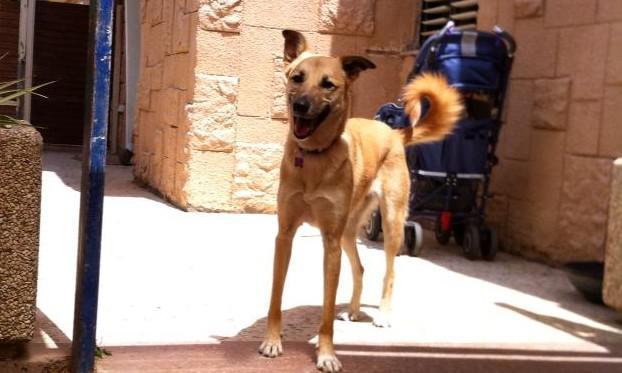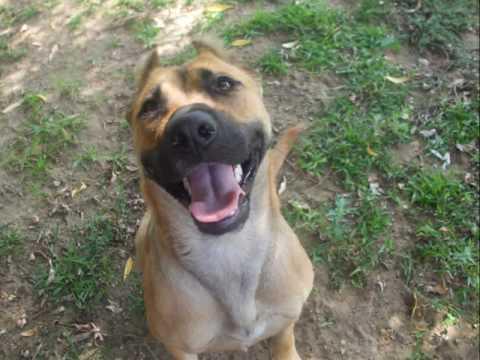The first image is the image on the left, the second image is the image on the right. Considering the images on both sides, is "The left image contains one person standing to the left of a dog." valid? Answer yes or no. No. The first image is the image on the left, the second image is the image on the right. For the images displayed, is the sentence "An image shows a person at the left, interacting with one big dog." factually correct? Answer yes or no. No. 